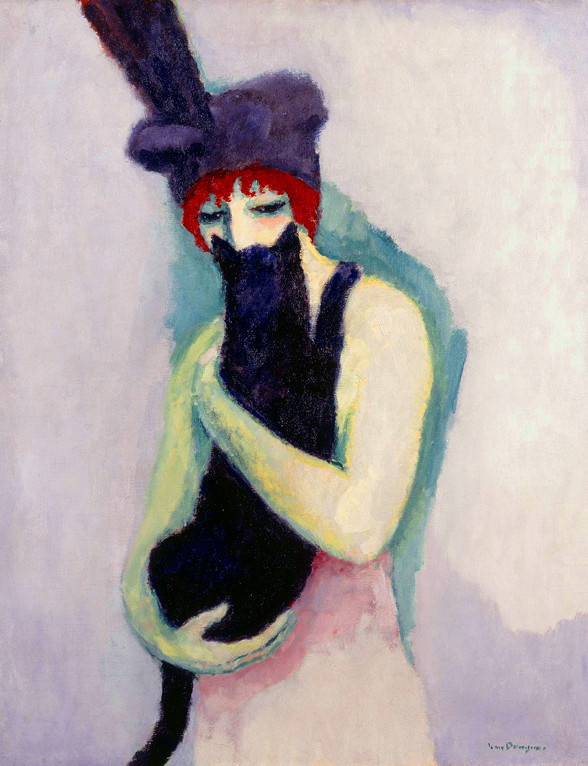Can you describe how the color palette contributes to the mood of the painting? The color palette, with its use of muted purples and blues against the lively shades of red and green, establishes a dreamlike, introspective ambiance. The contrast between the vibrant and muted colors draws attention to the central figure, emphasizing her emotional state, which appears contemplative and serene. The paleness of the background allows the subject and her companion to emerge as focal points, enhancing the sense of personal connection between them and adding depth to the portrayal of their relationship. 